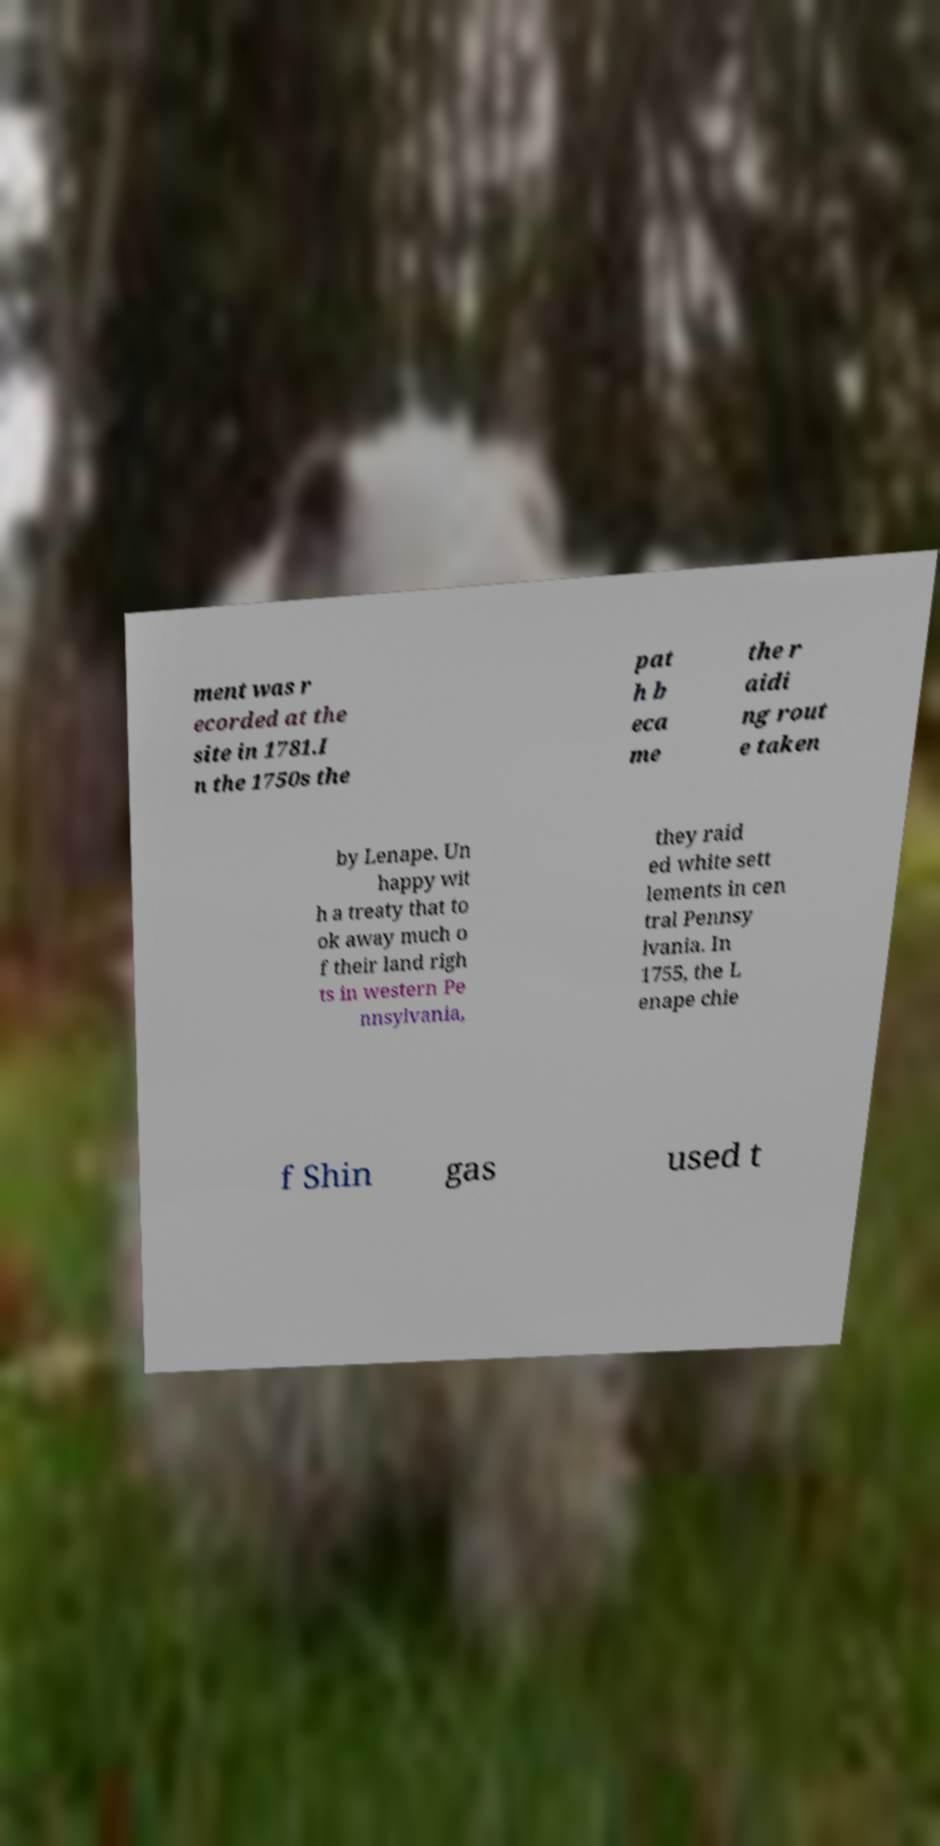Can you accurately transcribe the text from the provided image for me? ment was r ecorded at the site in 1781.I n the 1750s the pat h b eca me the r aidi ng rout e taken by Lenape. Un happy wit h a treaty that to ok away much o f their land righ ts in western Pe nnsylvania, they raid ed white sett lements in cen tral Pennsy lvania. In 1755, the L enape chie f Shin gas used t 